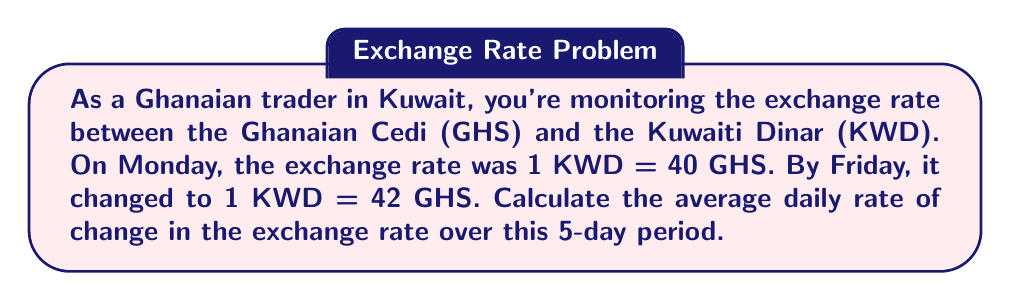Could you help me with this problem? To solve this problem, we'll use the average rate of change formula:

$$\text{Average rate of change} = \frac{\text{Change in y}}{\text{Change in x}}$$

Where:
- y represents the exchange rate (GHS per KWD)
- x represents time (in days)

Step 1: Determine the total change in exchange rate
Initial rate: 40 GHS/KWD
Final rate: 42 GHS/KWD
Total change: 42 - 40 = 2 GHS/KWD

Step 2: Determine the time period
From Monday to Friday is 5 days

Step 3: Apply the average rate of change formula
$$\text{Average daily rate of change} = \frac{42 \text{ GHS/KWD} - 40 \text{ GHS/KWD}}{5 \text{ days}}$$

$$= \frac{2 \text{ GHS/KWD}}{5 \text{ days}}$$

$$= 0.4 \text{ GHS/KWD per day}$$

Therefore, the average daily rate of change in the exchange rate is 0.4 GHS/KWD per day.
Answer: 0.4 GHS/KWD per day 